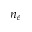<formula> <loc_0><loc_0><loc_500><loc_500>n _ { e }</formula> 